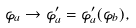<formula> <loc_0><loc_0><loc_500><loc_500>\varphi _ { a } \rightarrow \varphi ^ { \prime } _ { a } = \varphi ^ { \prime } _ { a } ( \varphi _ { b } ) ,</formula> 